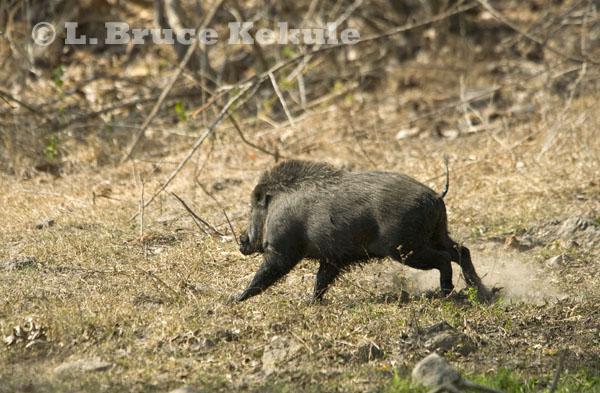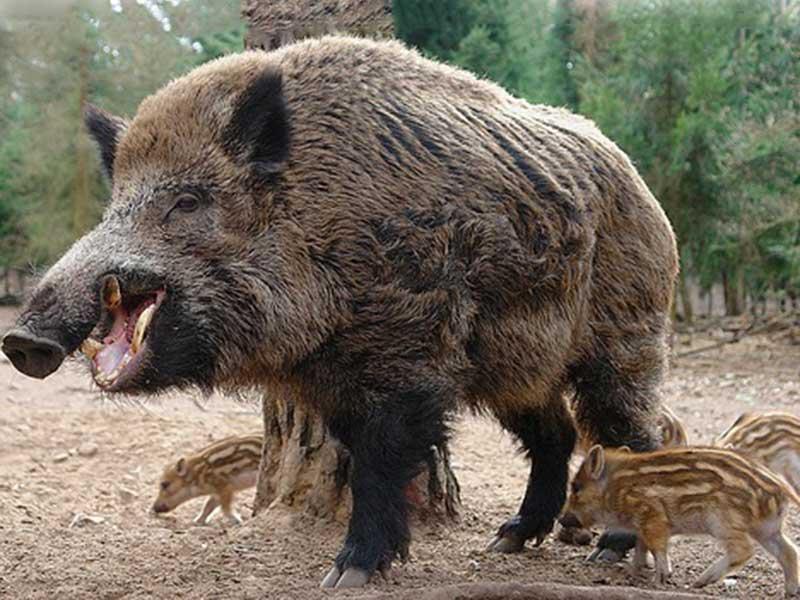The first image is the image on the left, the second image is the image on the right. Given the left and right images, does the statement "An image contains exactly two pigs, which are striped juveniles." hold true? Answer yes or no. No. The first image is the image on the left, the second image is the image on the right. Evaluate the accuracy of this statement regarding the images: "At least one of the animals in the image on the right has its mouth open.". Is it true? Answer yes or no. Yes. 